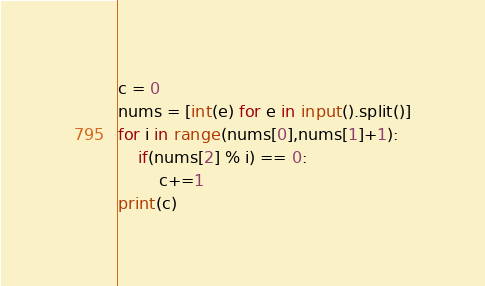Convert code to text. <code><loc_0><loc_0><loc_500><loc_500><_Python_>c = 0
nums = [int(e) for e in input().split()]
for i in range(nums[0],nums[1]+1):
    if(nums[2] % i) == 0:
        c+=1
print(c)

</code> 